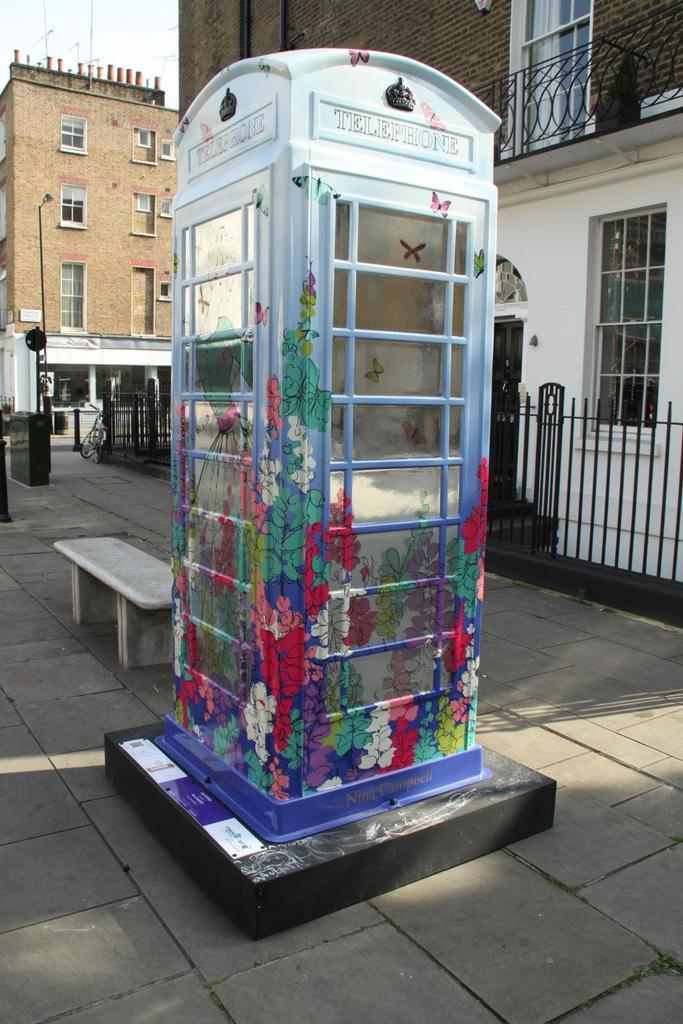What is the color of the telephone booth in the image? The telephone booth in the image is white. What type of seating is available in the image? There is a bench in the image. What structures can be seen in the background of the image? There are buildings visible in the image. What architectural feature is present in the image? There are windows in the image. What can be observed due to the presence of light in the image? Shadows are present in the image. What type of substance is being heated in the image? There is no substance being heated in the image. 